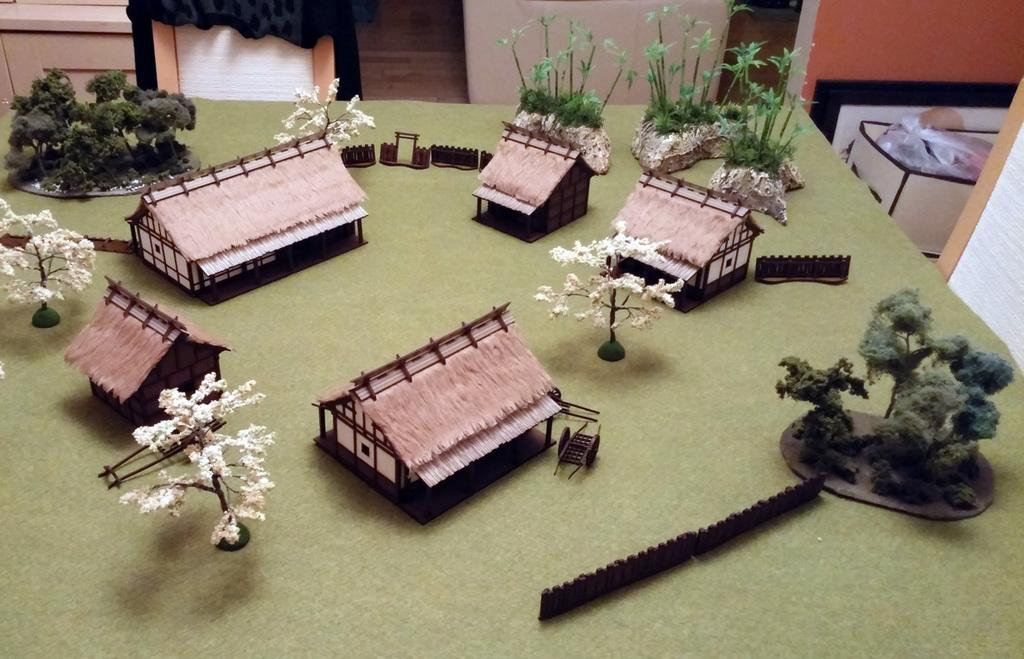What type of structures are depicted as building models in the image? There are building models of huts, fences, carts, hills, plants, and trees in the image. Can you describe the different types of building models present in the image? Yes, there are building models of huts, fences, carts, hills, plants, and trees in the image. What type of natural elements are represented as building models in the image? There are building models of hills, plants, and trees in the image. What type of arithmetic problem can be solved using the building models in the image? The building models in the image are not related to arithmetic problems; they are models of structures and natural elements. What type of hair can be seen on the building models of trees in the image? There are no representations of hair on the building models in the image, as they are models of structures and natural elements. 